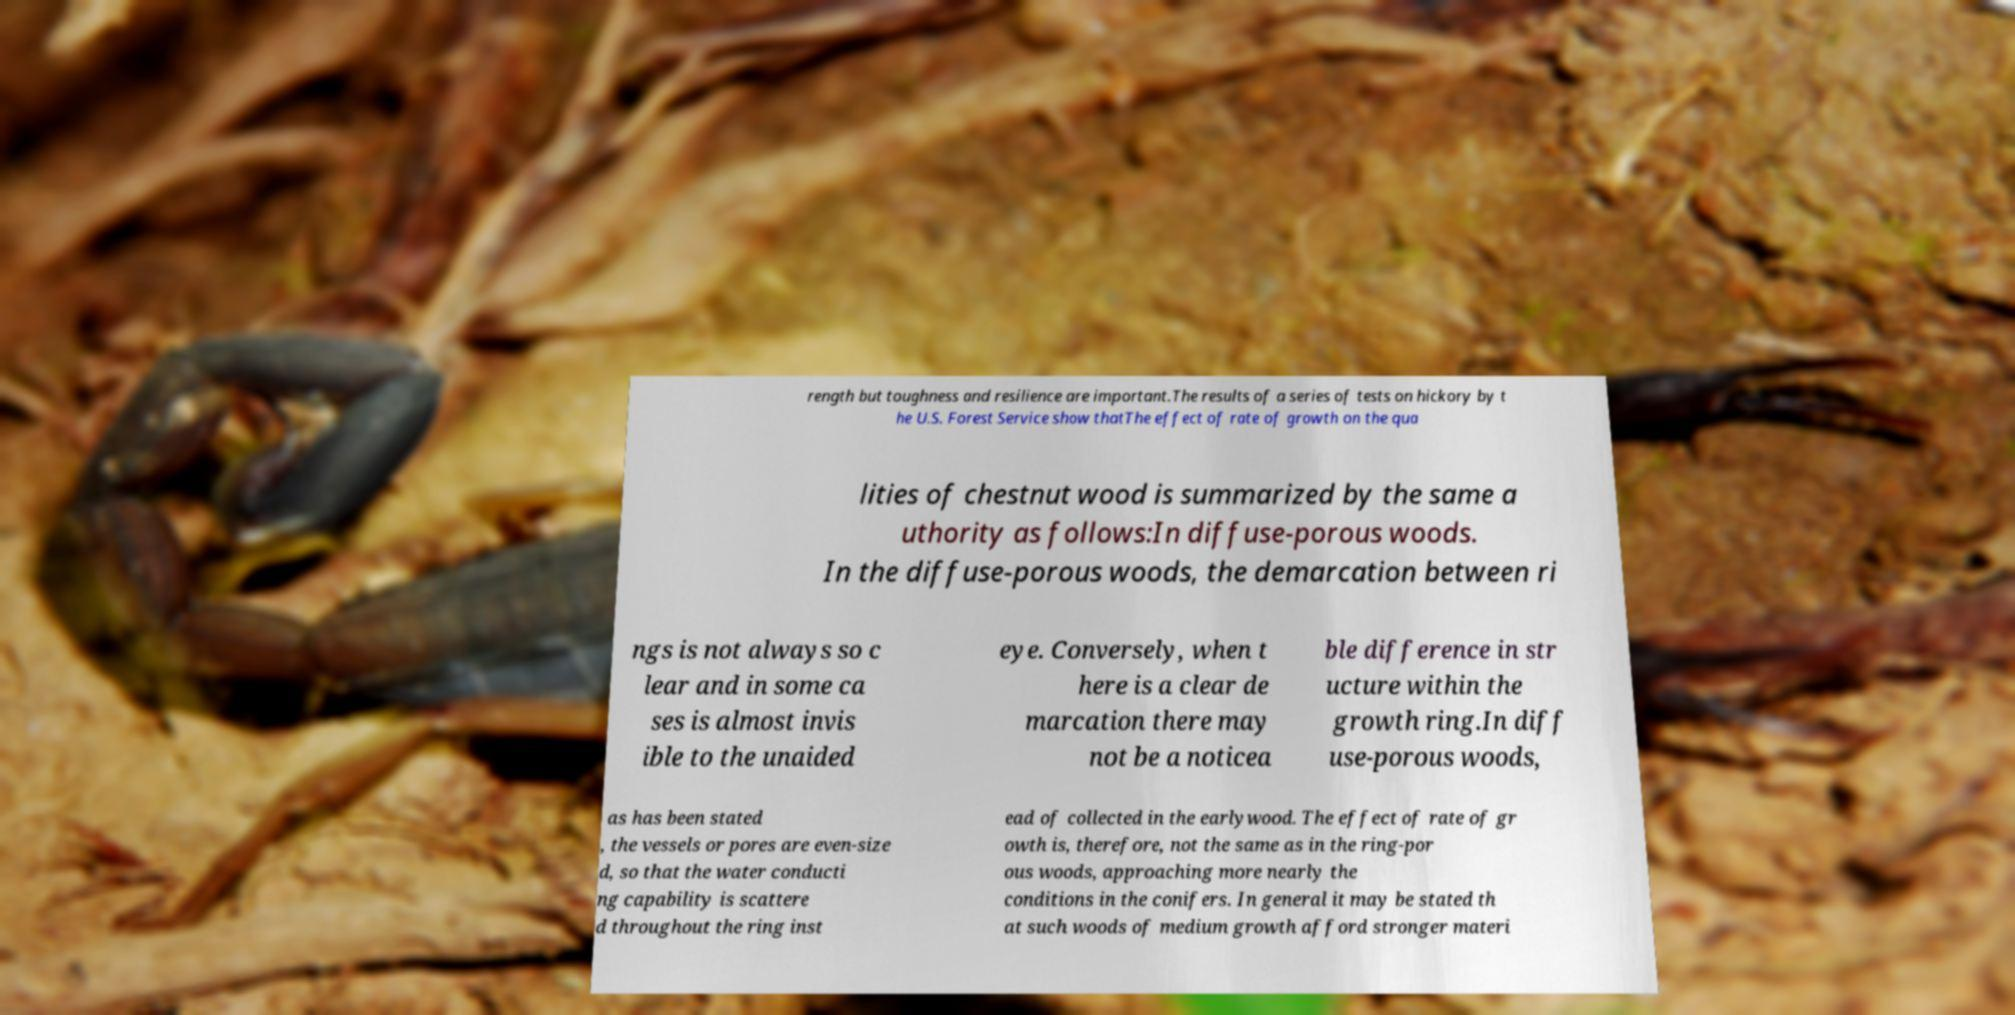Could you assist in decoding the text presented in this image and type it out clearly? rength but toughness and resilience are important.The results of a series of tests on hickory by t he U.S. Forest Service show thatThe effect of rate of growth on the qua lities of chestnut wood is summarized by the same a uthority as follows:In diffuse-porous woods. In the diffuse-porous woods, the demarcation between ri ngs is not always so c lear and in some ca ses is almost invis ible to the unaided eye. Conversely, when t here is a clear de marcation there may not be a noticea ble difference in str ucture within the growth ring.In diff use-porous woods, as has been stated , the vessels or pores are even-size d, so that the water conducti ng capability is scattere d throughout the ring inst ead of collected in the earlywood. The effect of rate of gr owth is, therefore, not the same as in the ring-por ous woods, approaching more nearly the conditions in the conifers. In general it may be stated th at such woods of medium growth afford stronger materi 